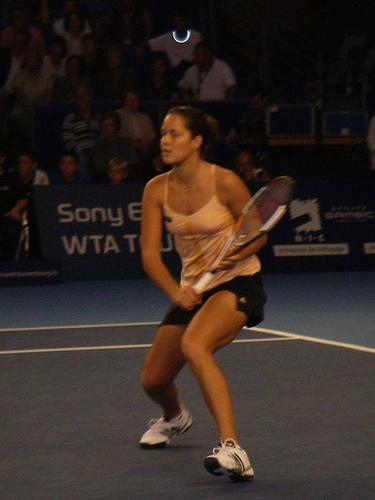What is the woman prepared to do?

Choices:
A) dunk
B) swing
C) run
D) dribble swing 